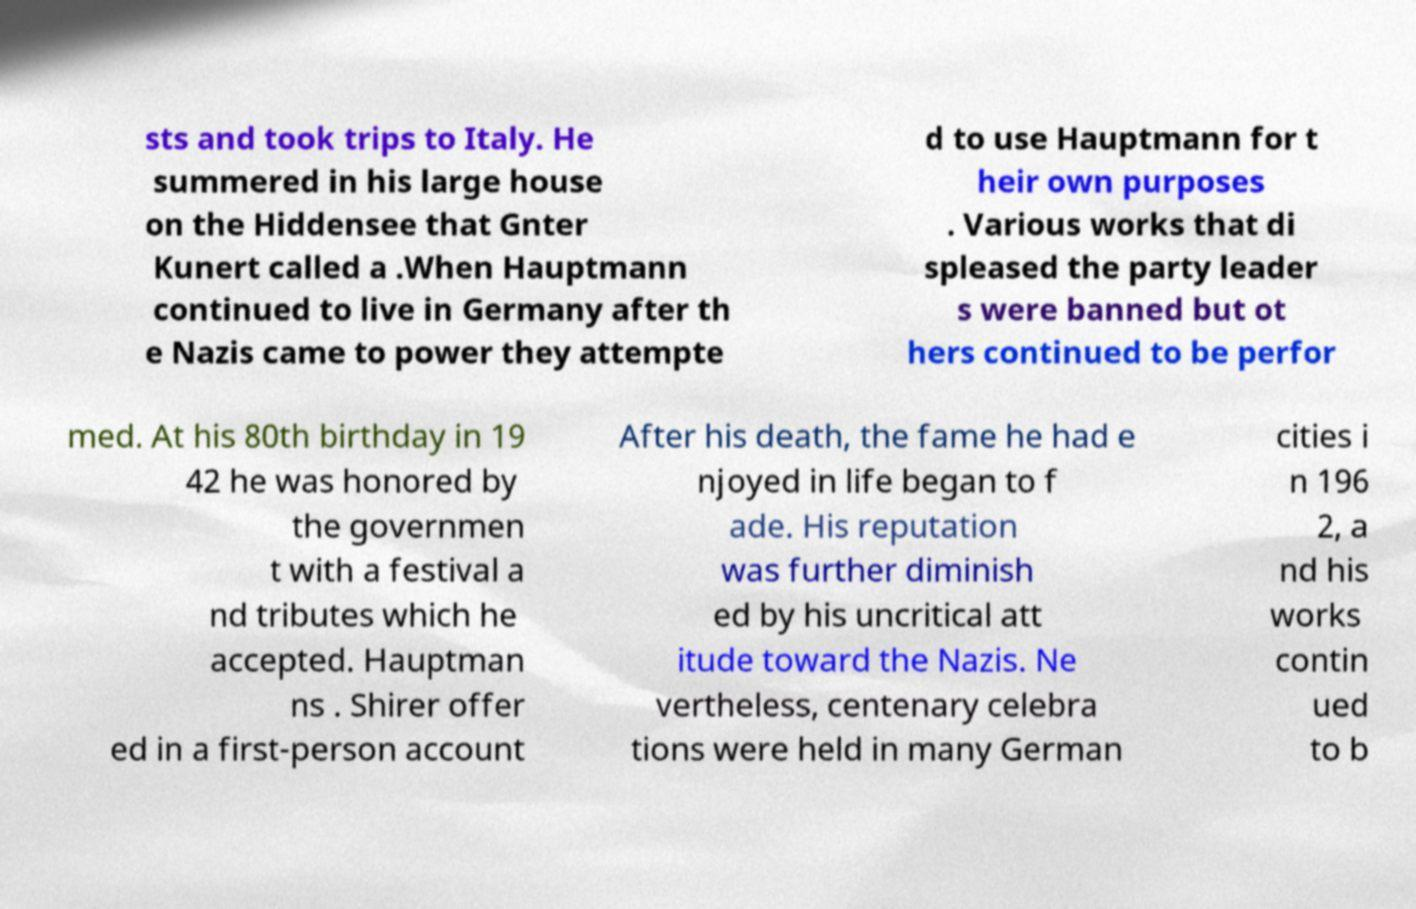What messages or text are displayed in this image? I need them in a readable, typed format. sts and took trips to Italy. He summered in his large house on the Hiddensee that Gnter Kunert called a .When Hauptmann continued to live in Germany after th e Nazis came to power they attempte d to use Hauptmann for t heir own purposes . Various works that di spleased the party leader s were banned but ot hers continued to be perfor med. At his 80th birthday in 19 42 he was honored by the governmen t with a festival a nd tributes which he accepted. Hauptman ns . Shirer offer ed in a first-person account After his death, the fame he had e njoyed in life began to f ade. His reputation was further diminish ed by his uncritical att itude toward the Nazis. Ne vertheless, centenary celebra tions were held in many German cities i n 196 2, a nd his works contin ued to b 